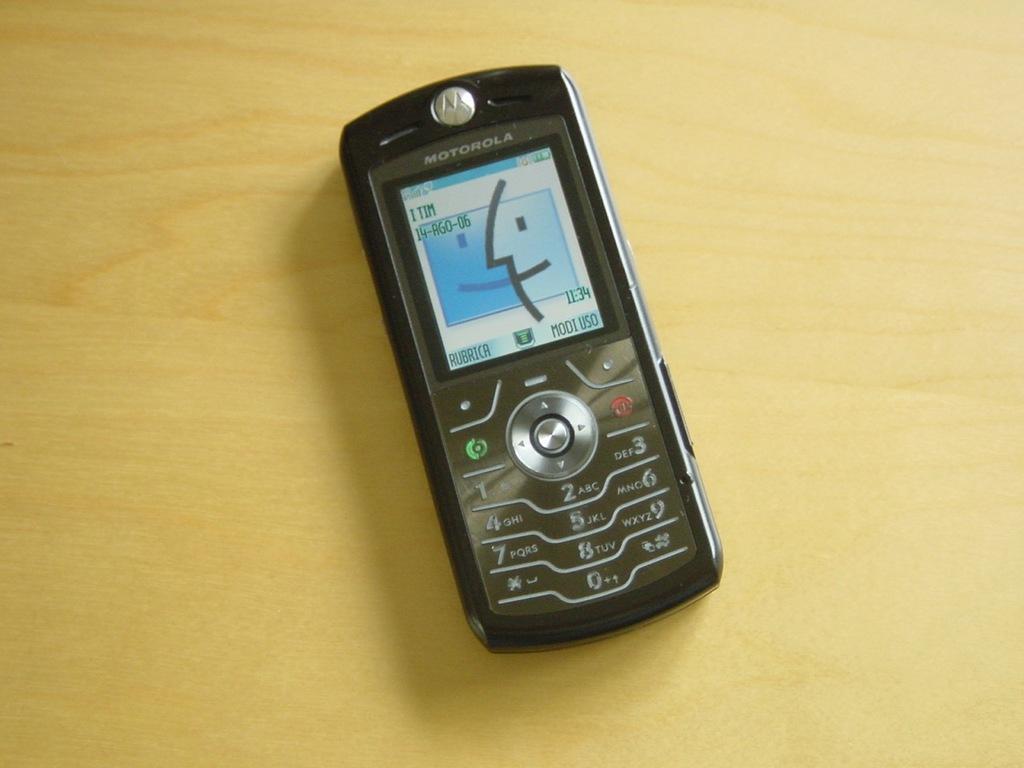Please provide a concise description of this image. In this picture, we see a black color mobile phone which is placed on the yellow color table. On top of the mobile phone, it is written as "MOTOROLA". 